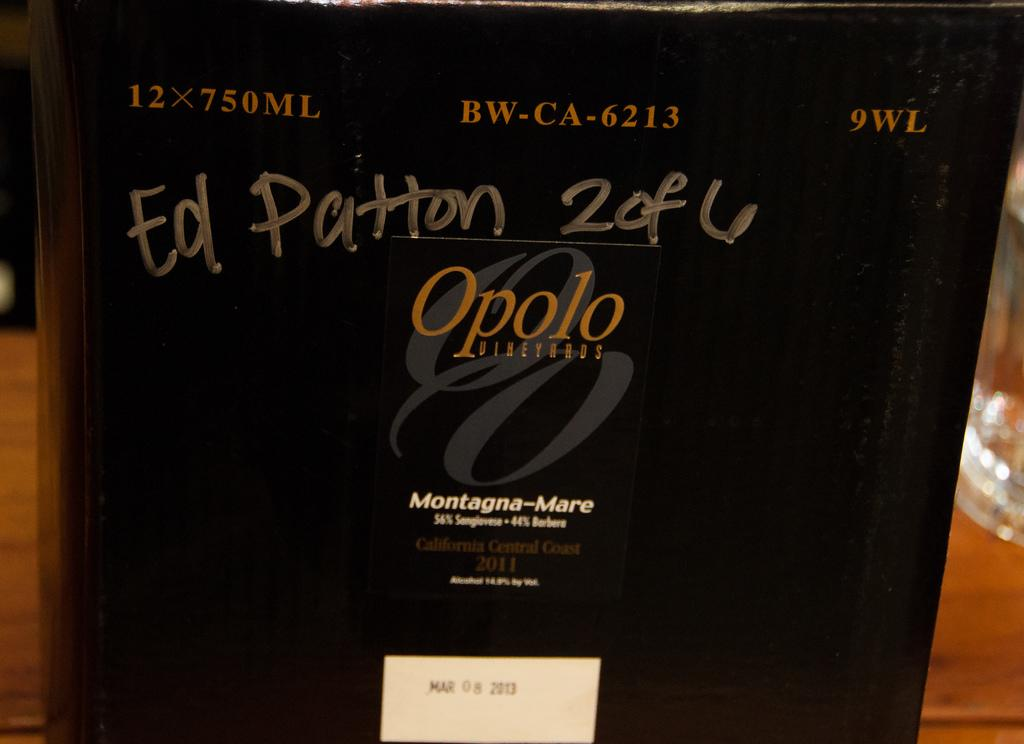<image>
Offer a succinct explanation of the picture presented. A large dark shaded bottle of Opolo wine in close up. 